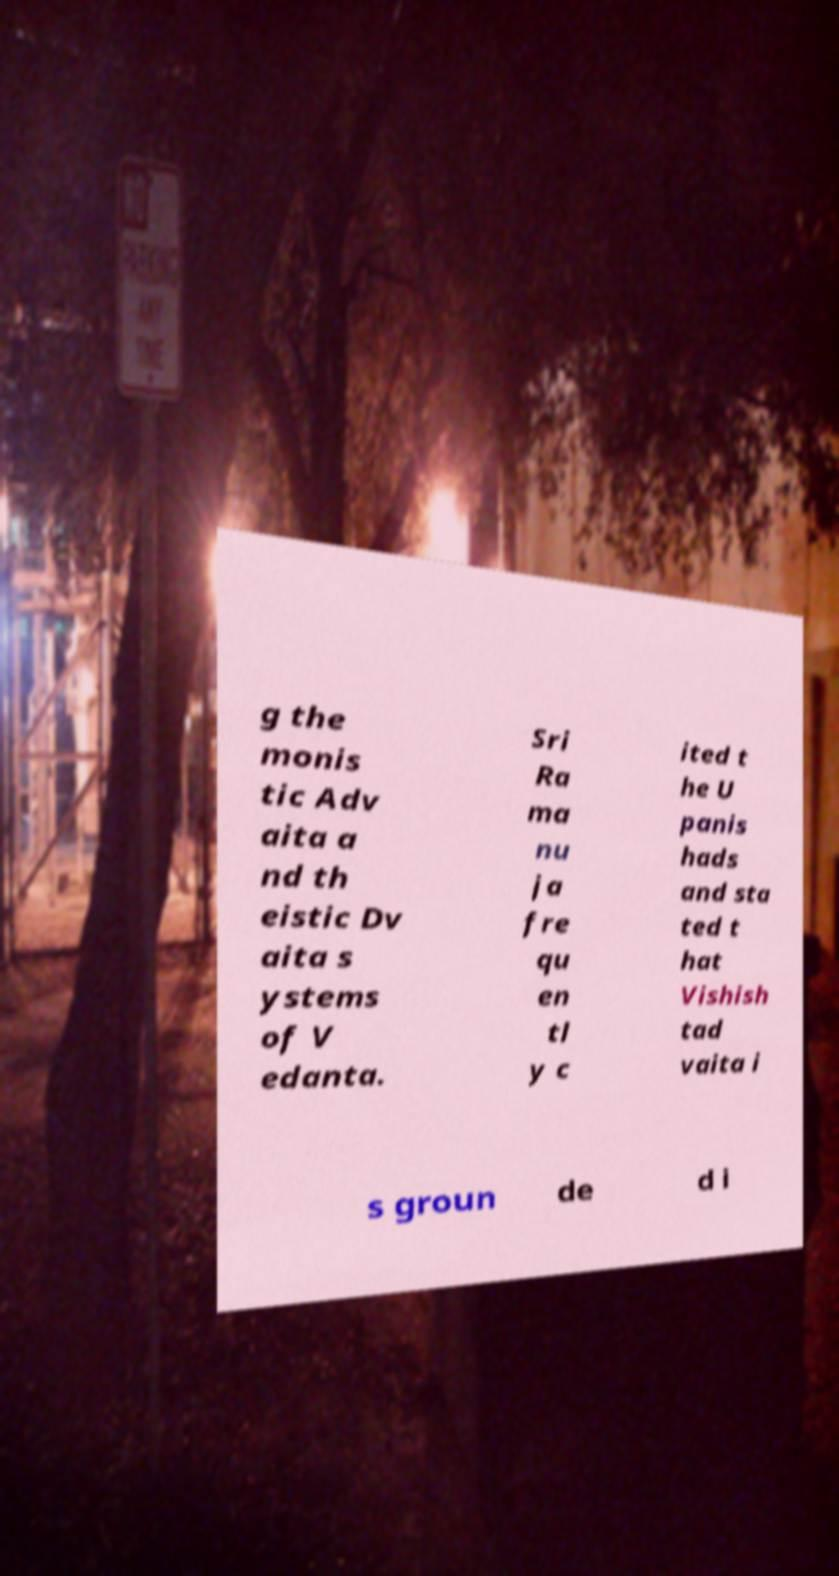Could you assist in decoding the text presented in this image and type it out clearly? g the monis tic Adv aita a nd th eistic Dv aita s ystems of V edanta. Sri Ra ma nu ja fre qu en tl y c ited t he U panis hads and sta ted t hat Vishish tad vaita i s groun de d i 